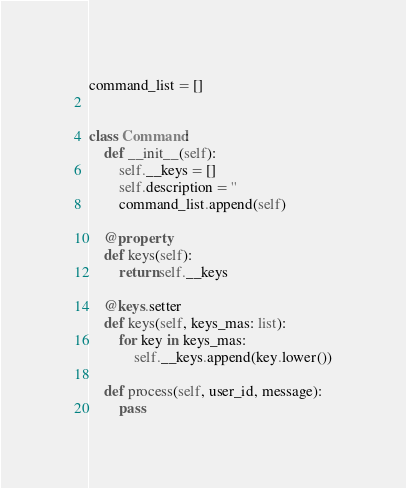<code> <loc_0><loc_0><loc_500><loc_500><_Python_>command_list = []


class Command:
    def __init__(self):
        self.__keys = []
        self.description = ''
        command_list.append(self)

    @property
    def keys(self):
        return self.__keys

    @keys.setter
    def keys(self, keys_mas: list):
        for key in keys_mas:
            self.__keys.append(key.lower())

    def process(self, user_id, message):
        pass
</code> 